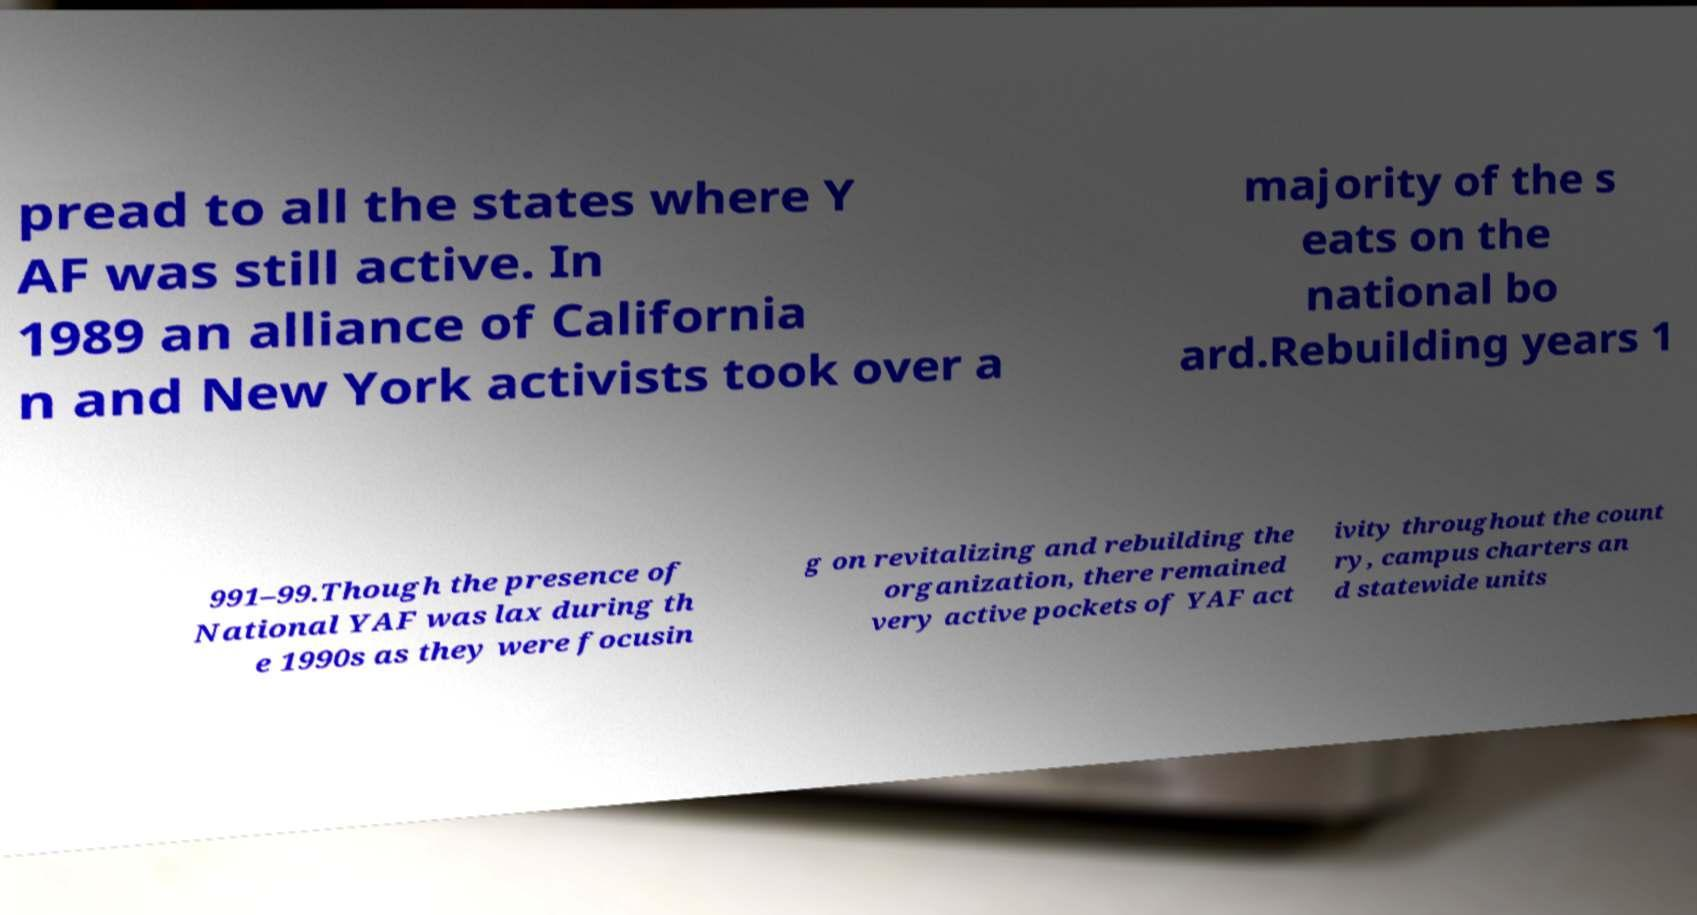I need the written content from this picture converted into text. Can you do that? pread to all the states where Y AF was still active. In 1989 an alliance of California n and New York activists took over a majority of the s eats on the national bo ard.Rebuilding years 1 991–99.Though the presence of National YAF was lax during th e 1990s as they were focusin g on revitalizing and rebuilding the organization, there remained very active pockets of YAF act ivity throughout the count ry, campus charters an d statewide units 